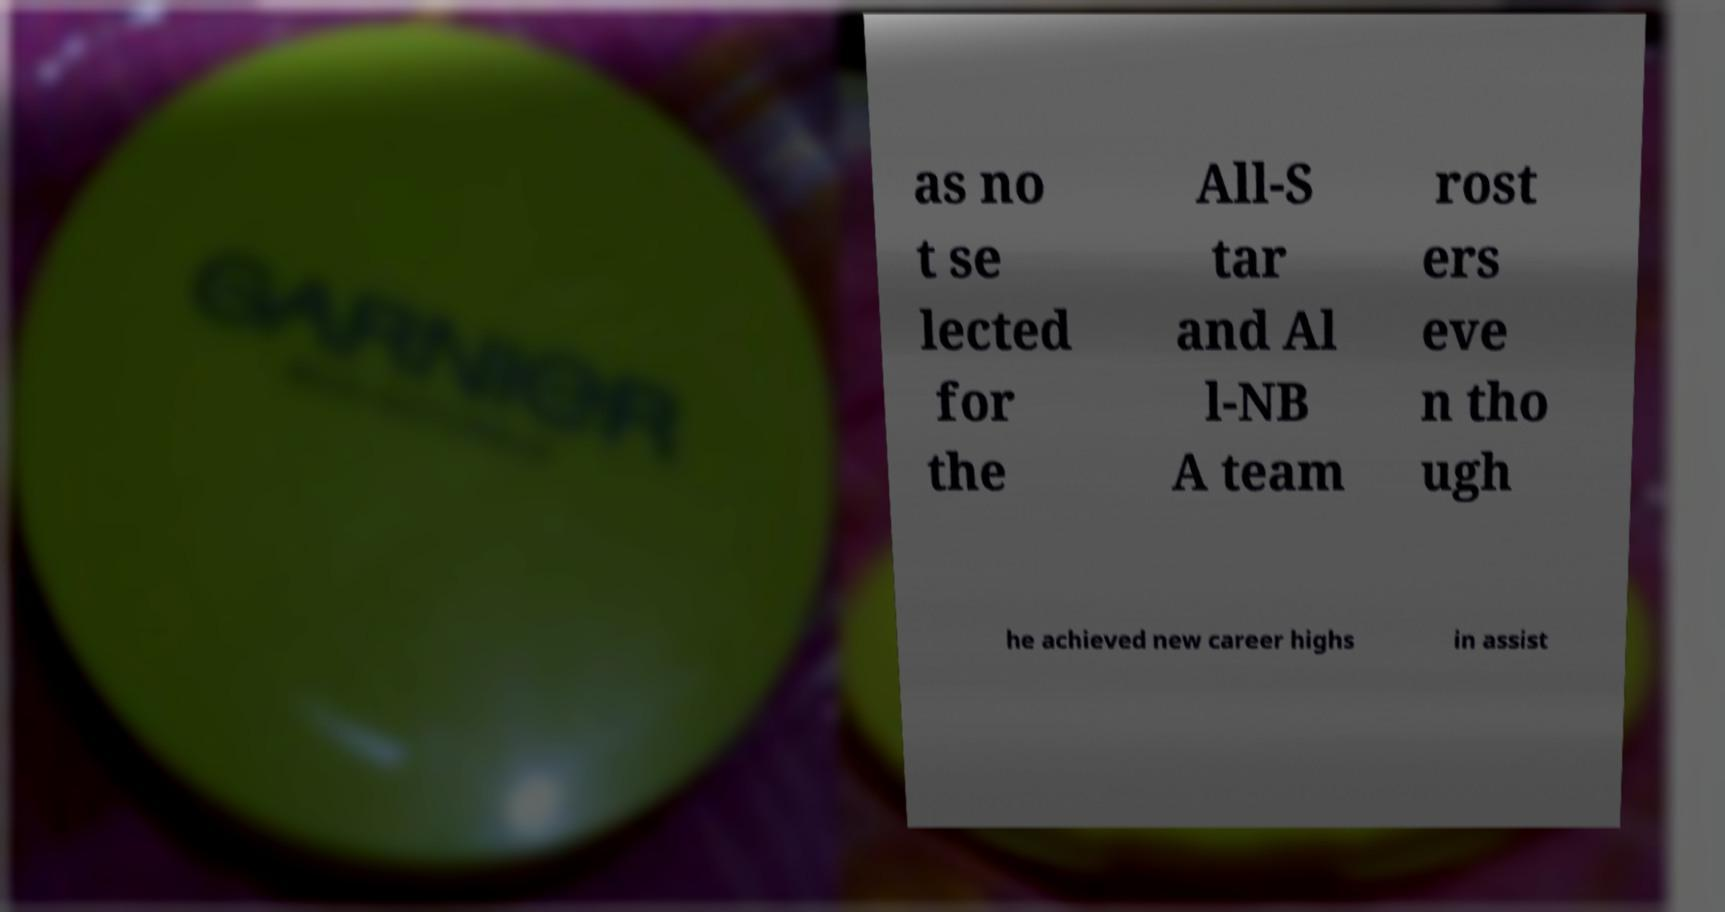Please identify and transcribe the text found in this image. as no t se lected for the All-S tar and Al l-NB A team rost ers eve n tho ugh he achieved new career highs in assist 